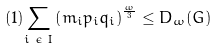<formula> <loc_0><loc_0><loc_500><loc_500>( 1 ) \underset { i \text { } \epsilon \text { } I } { \sum } \left ( m _ { i } p _ { i } q _ { i } \right ) ^ { \frac { \omega } { 3 } } \leq D _ { \omega } ( G )</formula> 